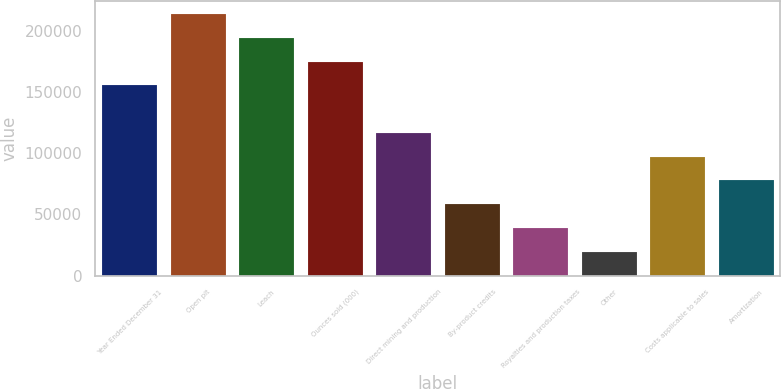Convert chart. <chart><loc_0><loc_0><loc_500><loc_500><bar_chart><fcel>Year Ended December 31<fcel>Open pit<fcel>Leach<fcel>Ounces sold (000)<fcel>Direct mining and production<fcel>By-product credits<fcel>Royalties and production taxes<fcel>Other<fcel>Costs applicable to sales<fcel>Amortization<nl><fcel>155274<fcel>213501<fcel>194092<fcel>174683<fcel>116456<fcel>58229.7<fcel>38820.8<fcel>19411.9<fcel>97047.5<fcel>77638.6<nl></chart> 